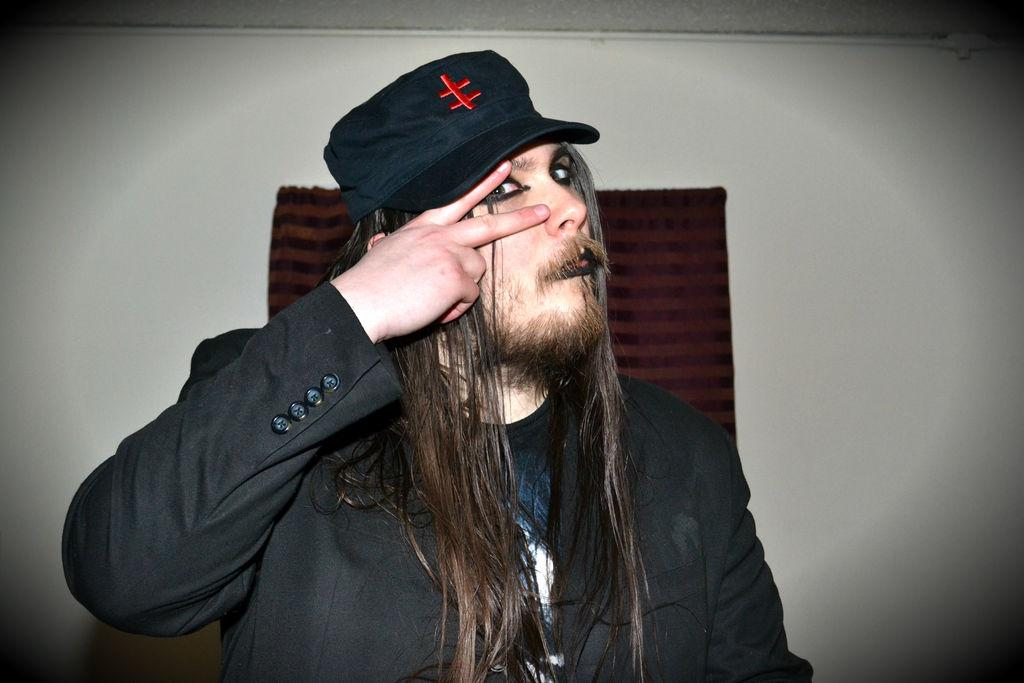What is the main subject of the image? There is a person sitting in the center of the image. What is the person wearing on their head? The person is wearing a cap. What type of clothing is the person wearing? The person is wearing a coat. What can be seen in the background of the image? There is a wall and a pipe visible in the background of the image. What type of treatment is the person receiving in the image? There is no indication of any treatment being administered in the image; it simply shows a person sitting with a cap and coat. Can you tell me how many sheep are present in the image? There are no sheep present in the image. 